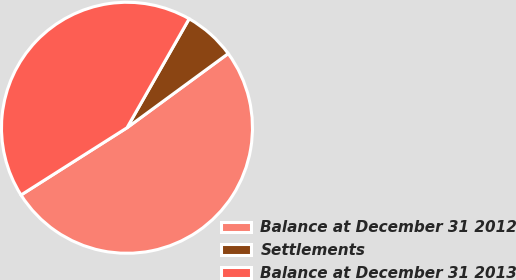Convert chart to OTSL. <chart><loc_0><loc_0><loc_500><loc_500><pie_chart><fcel>Balance at December 31 2012<fcel>Settlements<fcel>Balance at December 31 2013<nl><fcel>51.07%<fcel>6.68%<fcel>42.25%<nl></chart> 